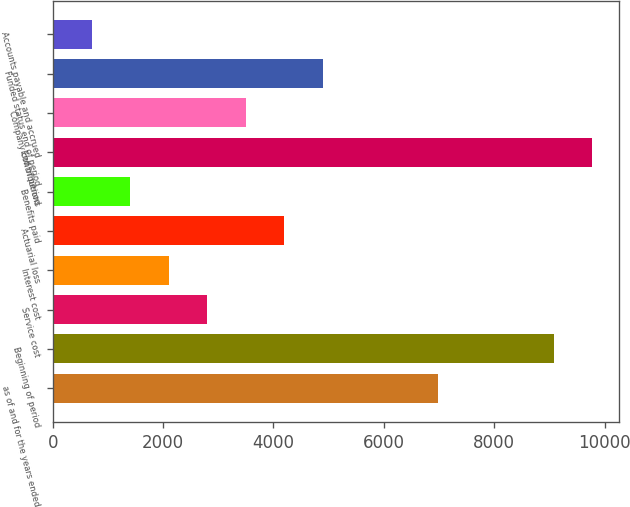<chart> <loc_0><loc_0><loc_500><loc_500><bar_chart><fcel>as of and for the years ended<fcel>Beginning of period<fcel>Service cost<fcel>Interest cost<fcel>Actuarial loss<fcel>Benefits paid<fcel>End of period<fcel>Company contributions<fcel>Funded status end of period<fcel>Accounts payable and accrued<nl><fcel>6985<fcel>9076.9<fcel>2801.2<fcel>2103.9<fcel>4195.8<fcel>1406.6<fcel>9774.2<fcel>3498.5<fcel>4893.1<fcel>709.3<nl></chart> 